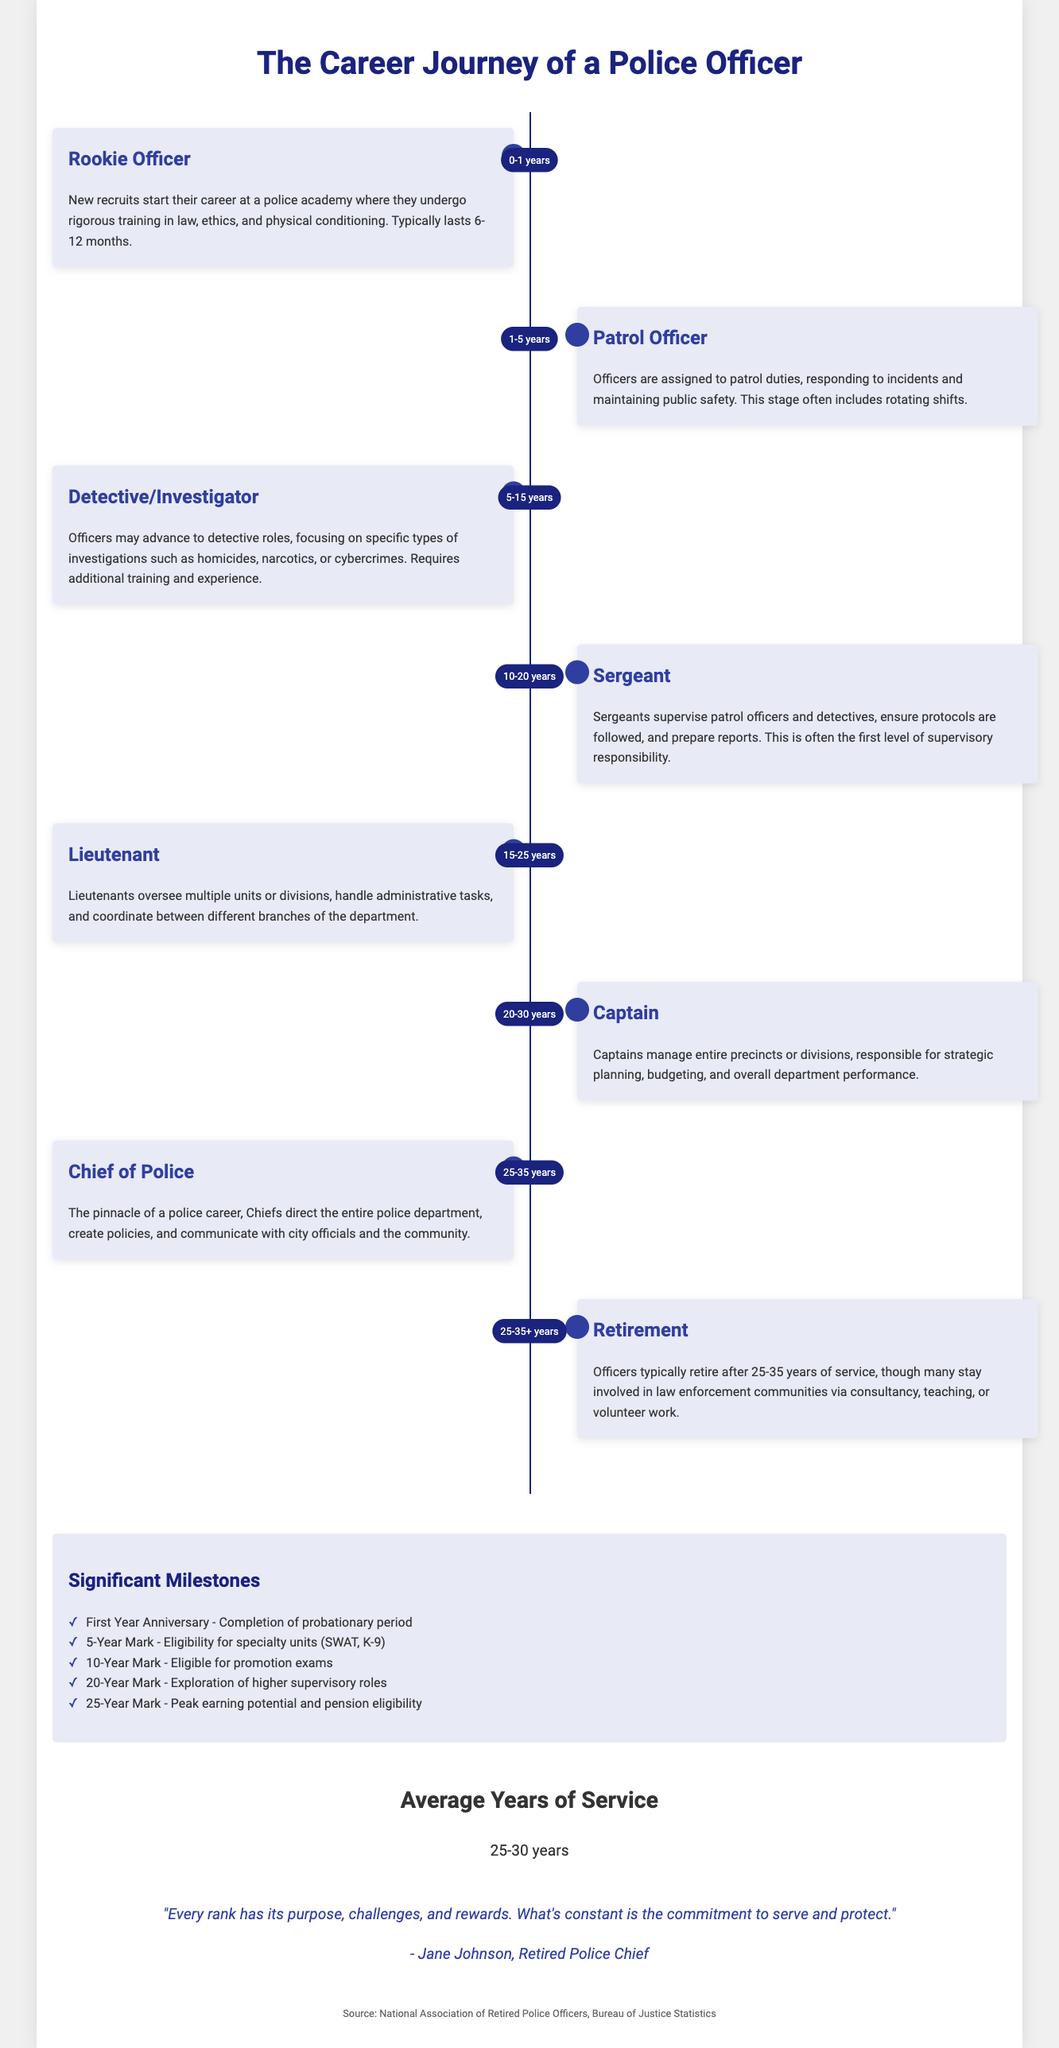What is the first stage of a police officer's career? The timeline marks the first stage of a police officer's career as "Rookie Officer."
Answer: Rookie Officer How long does the Rookie Officer stage typically last? The document states that the Rookie Officer stage typically lasts 6-12 months.
Answer: 6-12 months What is the average years of service for retired police officers? The document provides an average years of service as 25-30 years.
Answer: 25-30 years What milestone occurs at the 10-year mark? According to the document, at the 10-year mark, officers become eligible for promotion exams.
Answer: Eligible for promotion exams Which rank is considered the pinnacle of a police career? The document identifies the "Chief of Police" as the pinnacle of a police career.
Answer: Chief of Police During which stage do officers typically become detectives? Officers typically advance to detective roles during the "Detective/Investigator" stage.
Answer: Detective/Investigator What significant milestone is reached after 25 years of service? After 25 years of service, officers reach "peak earning potential and pension eligibility."
Answer: Peak earning potential and pension eligibility What role do lieutenants primarily oversee? Lieutenants primarily oversee multiple units or divisions in the police department.
Answer: Multiple units or divisions What percentage of a police officer's career is generally spent at the captain level? The timeline shows that officers typically spend between 20-30 years at the captain level.
Answer: 20-30 years 